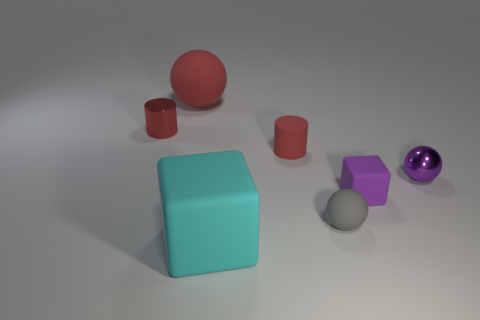How many small things are purple matte objects or metallic objects?
Provide a short and direct response. 3. The small metal thing that is the same shape as the gray matte object is what color?
Offer a terse response. Purple. Is the red rubber sphere the same size as the gray matte ball?
Offer a very short reply. No. How many objects are either blue rubber blocks or big objects left of the cyan rubber object?
Make the answer very short. 1. The rubber ball in front of the matte cylinder to the right of the big cyan object is what color?
Your response must be concise. Gray. There is a ball behind the small purple ball; is it the same color as the rubber cylinder?
Keep it short and to the point. Yes. What is the material of the large thing that is behind the small red shiny thing?
Provide a succinct answer. Rubber. The cyan matte object has what size?
Offer a very short reply. Large. Does the large object that is in front of the tiny gray matte ball have the same material as the gray sphere?
Your response must be concise. Yes. How many small cylinders are there?
Your answer should be very brief. 2. 